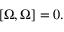Convert formula to latex. <formula><loc_0><loc_0><loc_500><loc_500>\left [ \Omega , \Omega \right ] = 0 .</formula> 